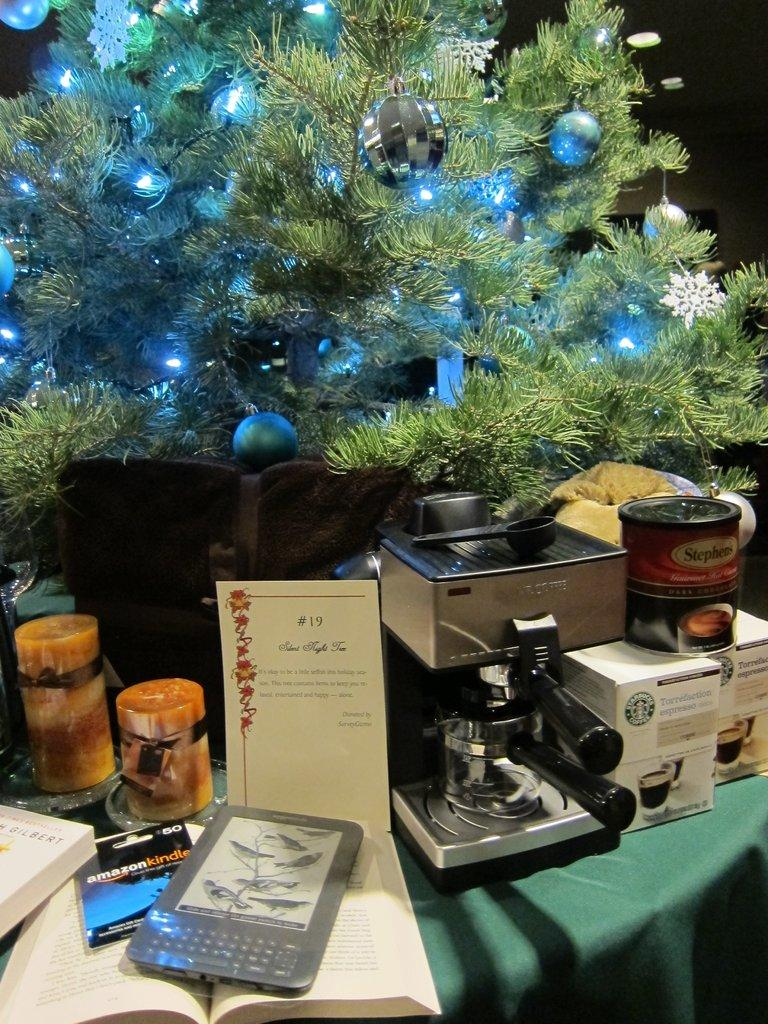What electronic device is visible in the image? There is a Kindle in the image. What type of reading material is also present in the image? There is a book in the image. How many glass jars can be seen in the image? There are two glass jars in the image. What appliance is on the table in the image? There is a coffee machine on a table in the image. What seasonal decoration is visible behind the table in the image? There is a Christmas tree behind the table in the image. What type of fruit is being sold by the cart in the image? There is no cart present in the image, so it is not possible to answer that question. 